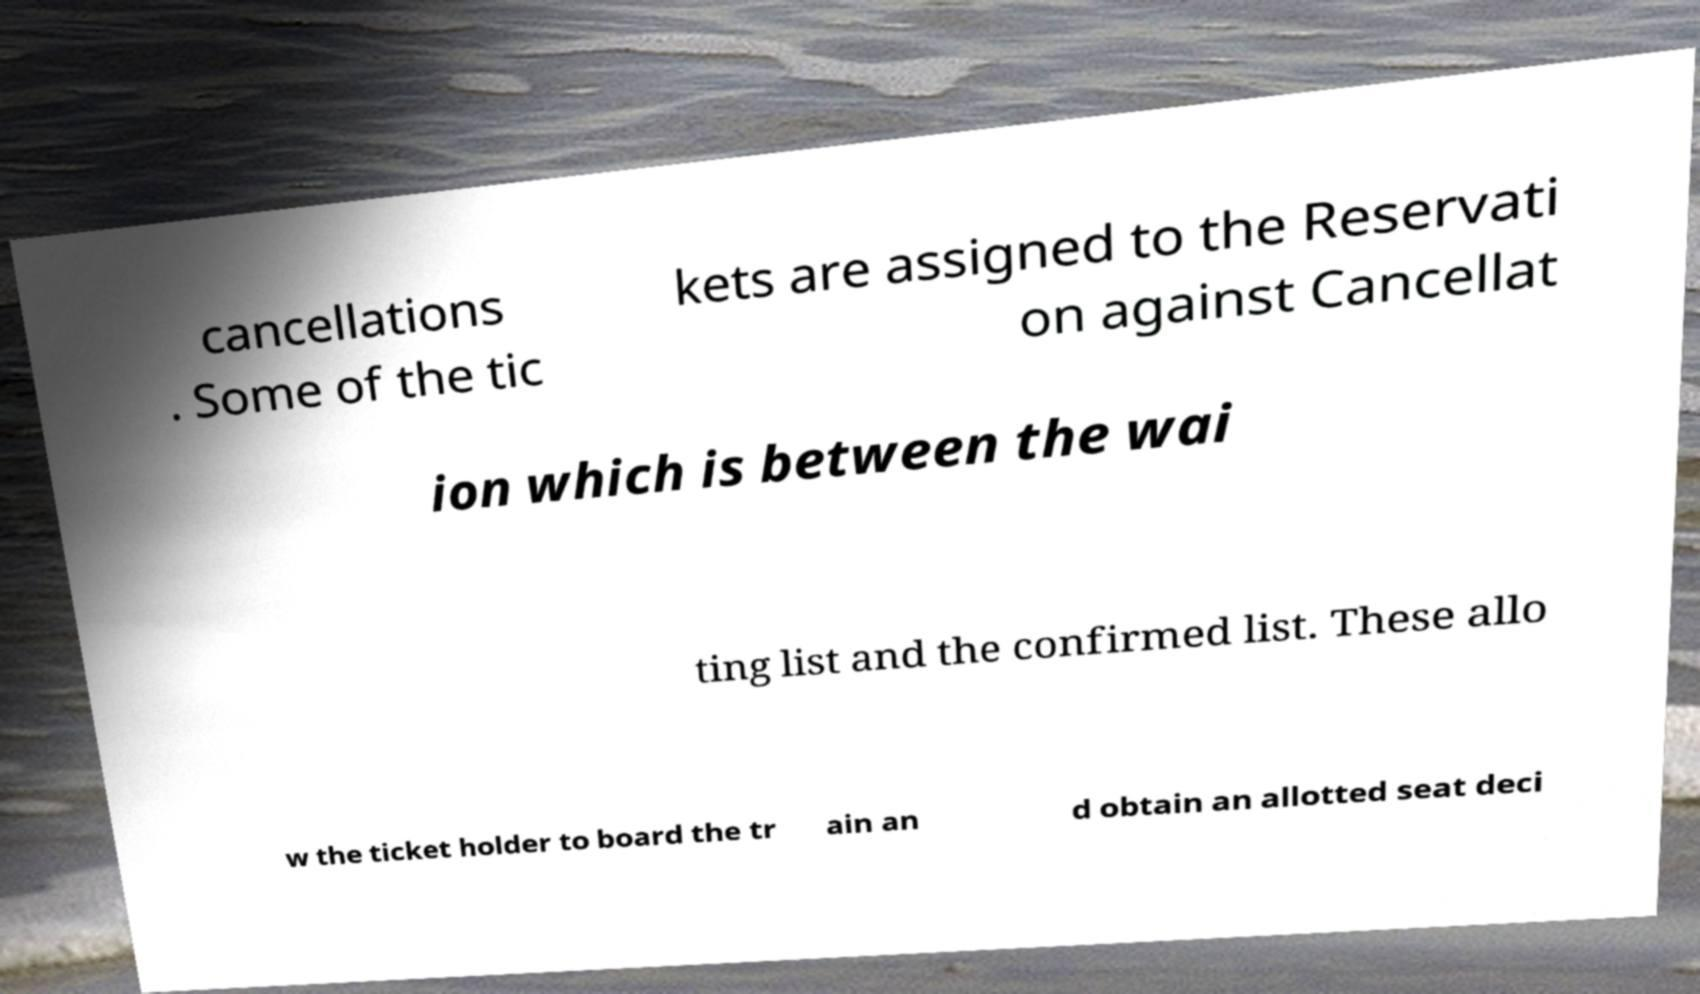There's text embedded in this image that I need extracted. Can you transcribe it verbatim? cancellations . Some of the tic kets are assigned to the Reservati on against Cancellat ion which is between the wai ting list and the confirmed list. These allo w the ticket holder to board the tr ain an d obtain an allotted seat deci 